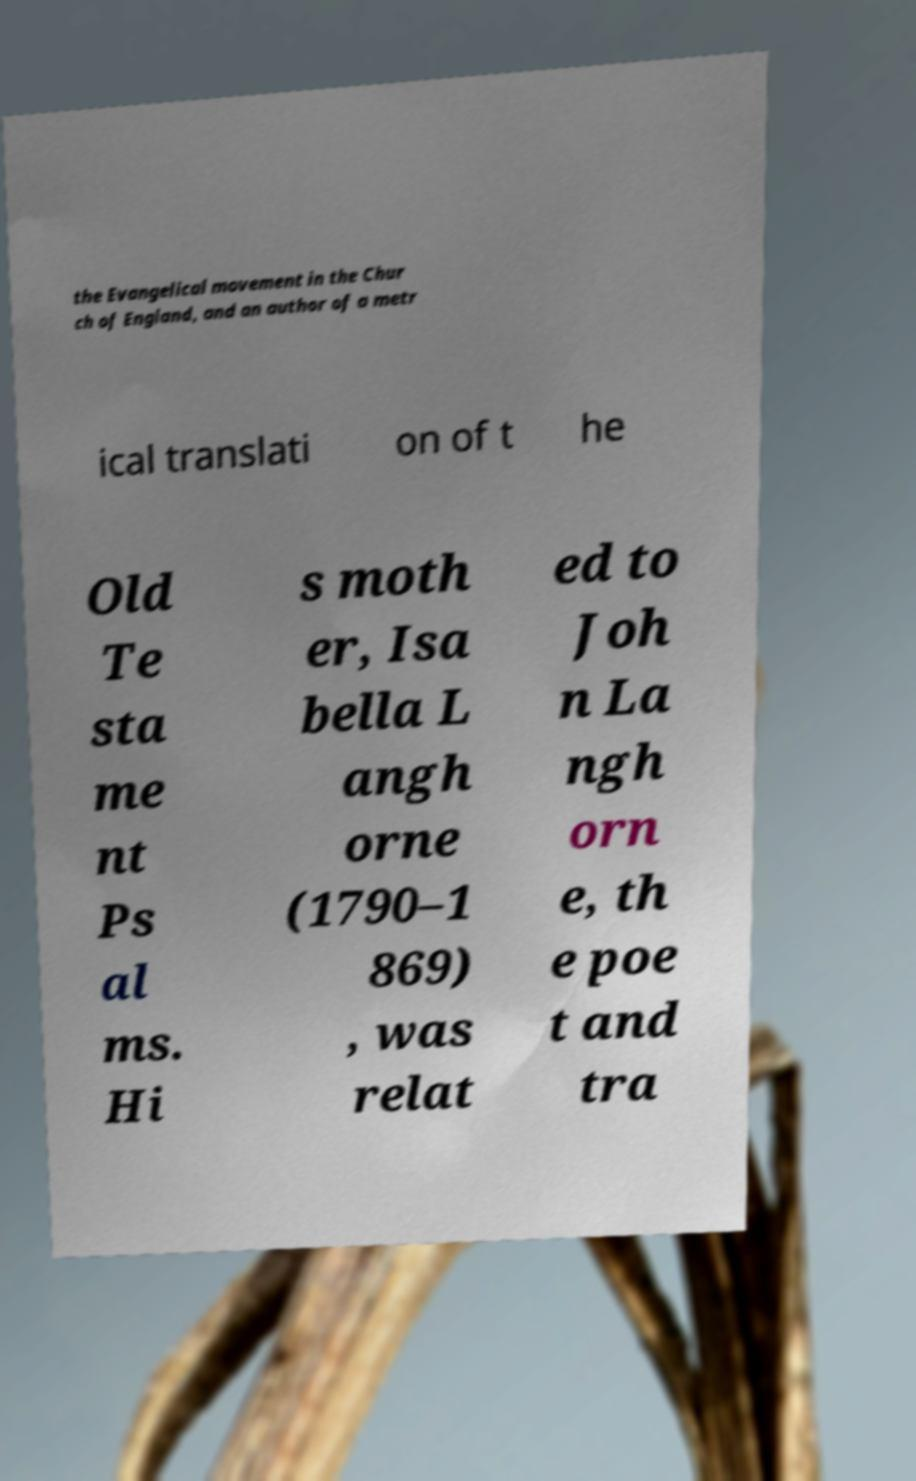For documentation purposes, I need the text within this image transcribed. Could you provide that? the Evangelical movement in the Chur ch of England, and an author of a metr ical translati on of t he Old Te sta me nt Ps al ms. Hi s moth er, Isa bella L angh orne (1790–1 869) , was relat ed to Joh n La ngh orn e, th e poe t and tra 